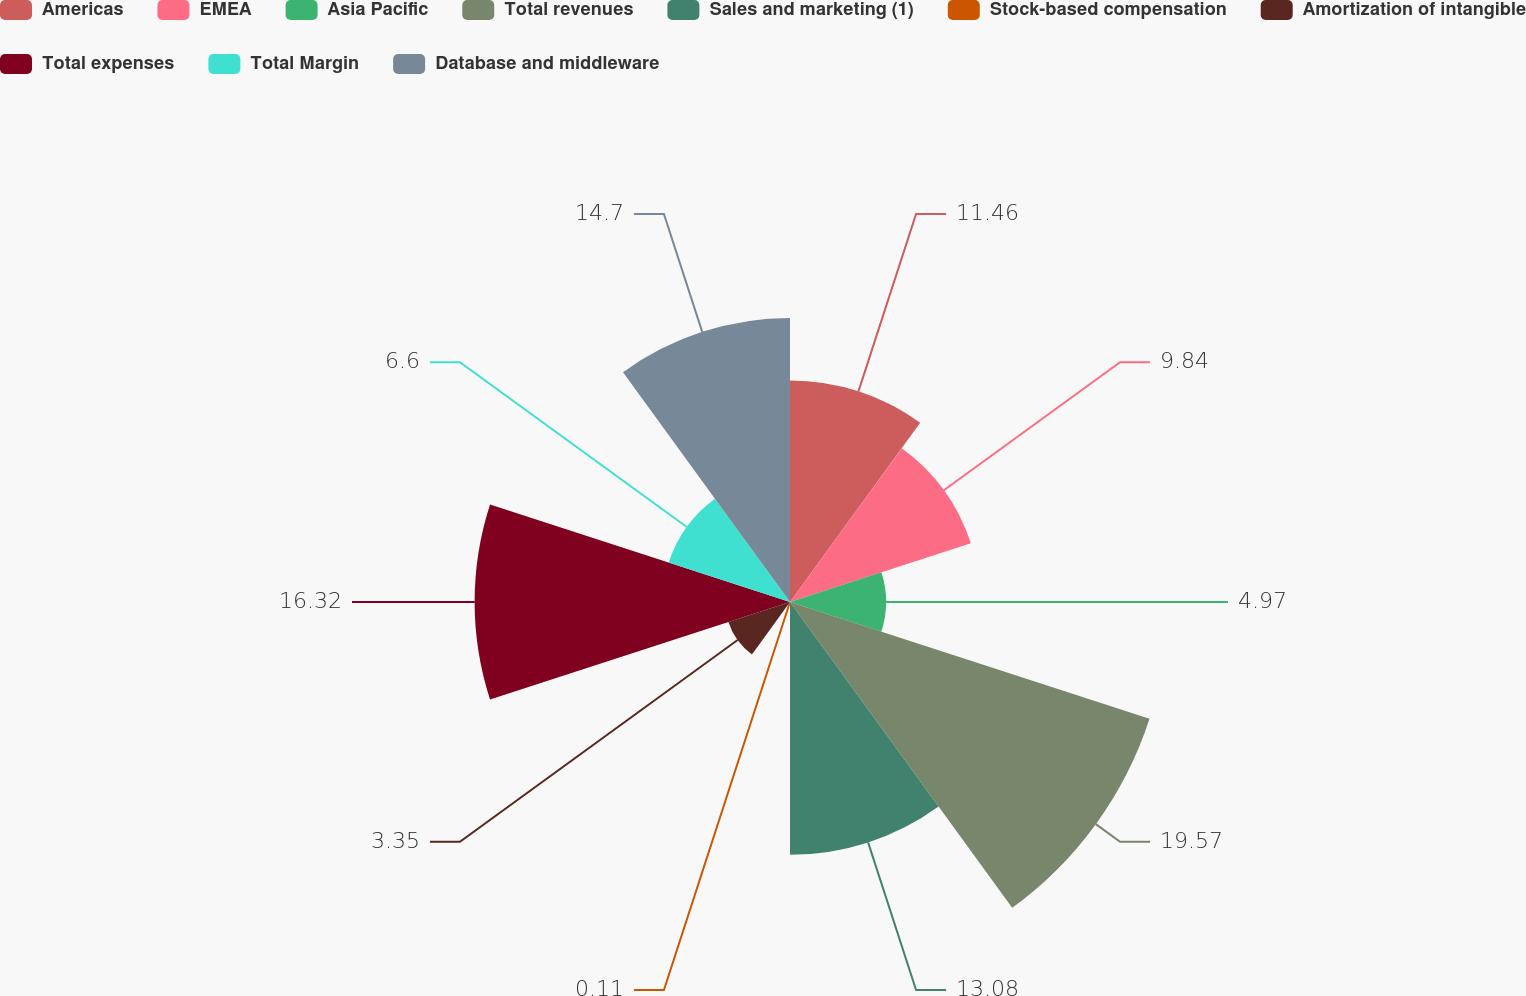Convert chart to OTSL. <chart><loc_0><loc_0><loc_500><loc_500><pie_chart><fcel>Americas<fcel>EMEA<fcel>Asia Pacific<fcel>Total revenues<fcel>Sales and marketing (1)<fcel>Stock-based compensation<fcel>Amortization of intangible<fcel>Total expenses<fcel>Total Margin<fcel>Database and middleware<nl><fcel>11.46%<fcel>9.84%<fcel>4.97%<fcel>19.56%<fcel>13.08%<fcel>0.11%<fcel>3.35%<fcel>16.32%<fcel>6.6%<fcel>14.7%<nl></chart> 